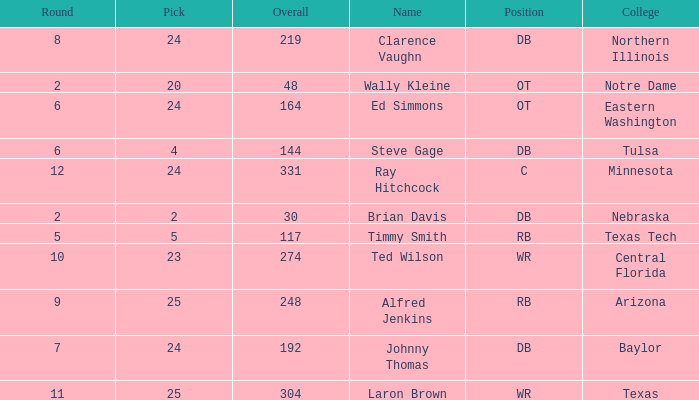What top round has a pick smaller than 2? None. 